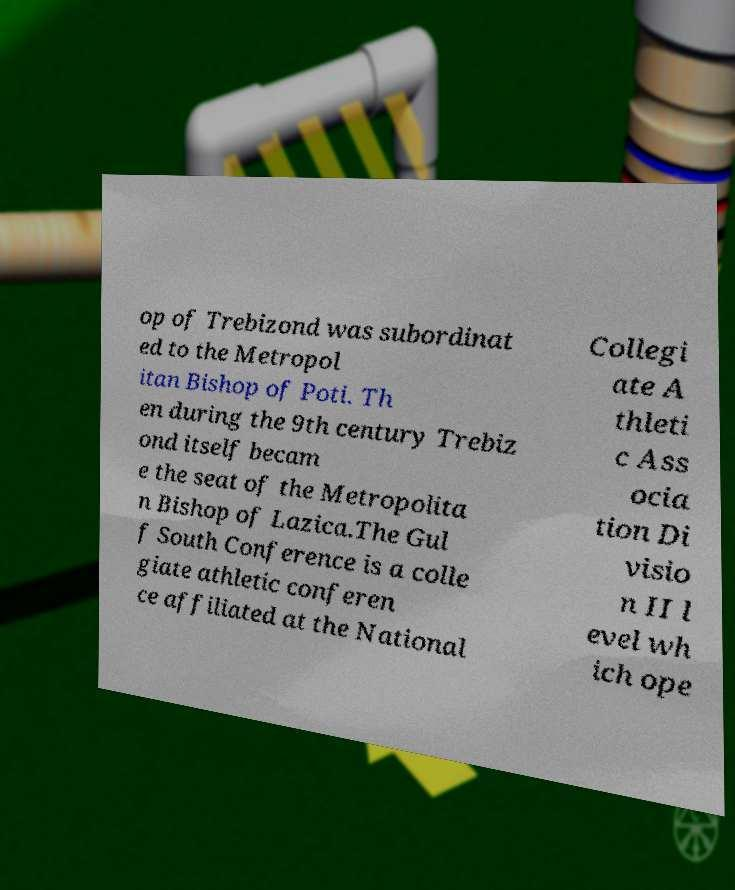Could you assist in decoding the text presented in this image and type it out clearly? op of Trebizond was subordinat ed to the Metropol itan Bishop of Poti. Th en during the 9th century Trebiz ond itself becam e the seat of the Metropolita n Bishop of Lazica.The Gul f South Conference is a colle giate athletic conferen ce affiliated at the National Collegi ate A thleti c Ass ocia tion Di visio n II l evel wh ich ope 